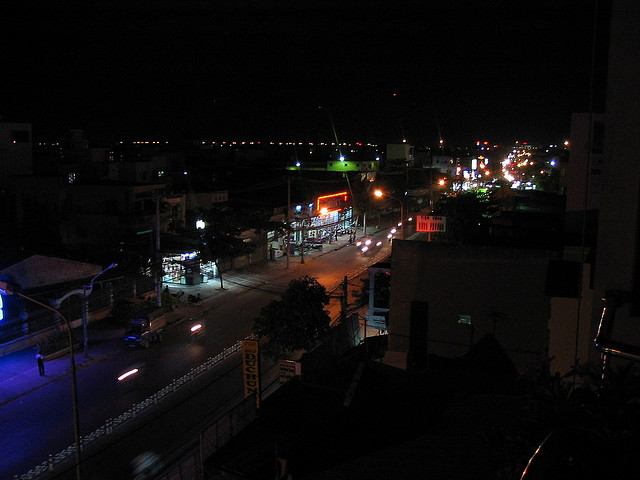Please transcribe the text in this image. ADUIDZ 